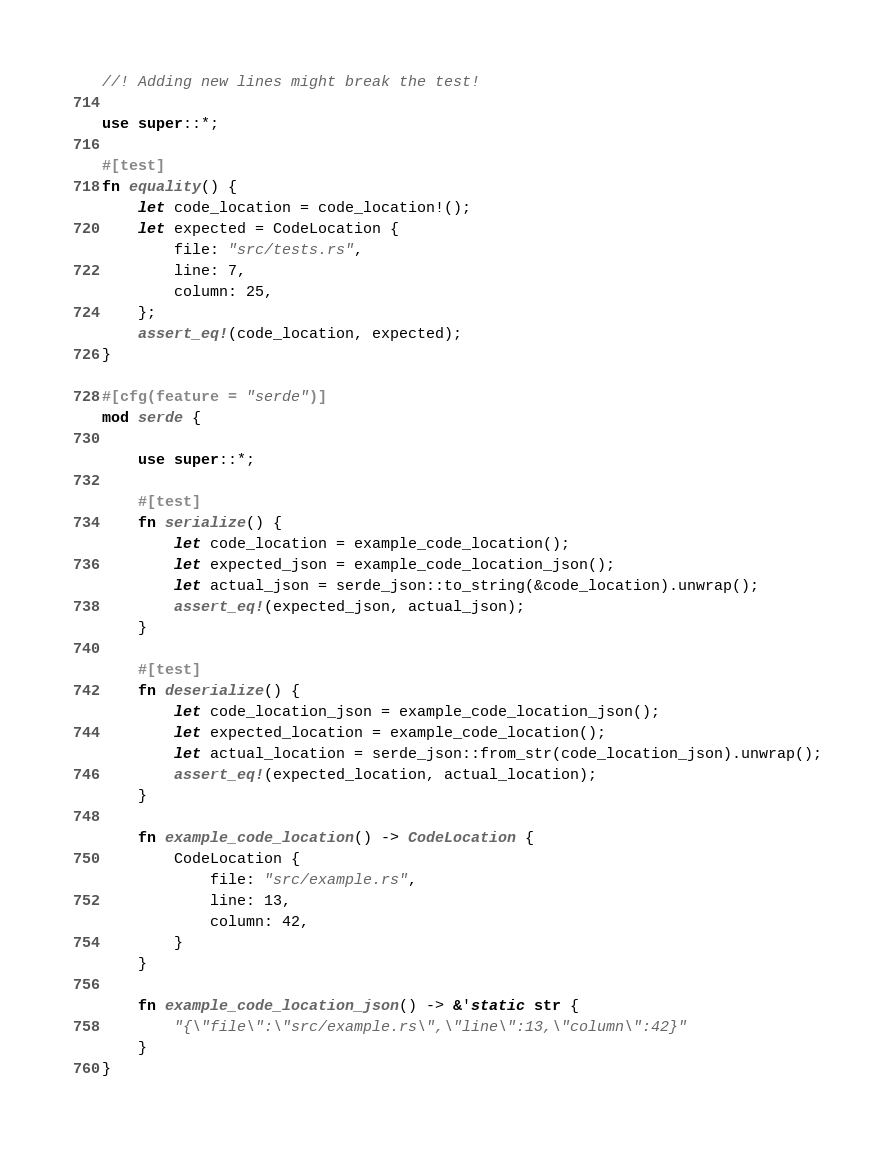Convert code to text. <code><loc_0><loc_0><loc_500><loc_500><_Rust_>//! Adding new lines might break the test!

use super::*;

#[test]
fn equality() {
    let code_location = code_location!();
    let expected = CodeLocation {
        file: "src/tests.rs",
        line: 7,
        column: 25,
    };
    assert_eq!(code_location, expected);
}

#[cfg(feature = "serde")]
mod serde {

    use super::*;

    #[test]
    fn serialize() {
        let code_location = example_code_location();
        let expected_json = example_code_location_json();
        let actual_json = serde_json::to_string(&code_location).unwrap();
        assert_eq!(expected_json, actual_json);
    }

    #[test]
    fn deserialize() {
        let code_location_json = example_code_location_json();
        let expected_location = example_code_location();
        let actual_location = serde_json::from_str(code_location_json).unwrap();
        assert_eq!(expected_location, actual_location);
    }

    fn example_code_location() -> CodeLocation {
        CodeLocation {
            file: "src/example.rs",
            line: 13,
            column: 42,
        }
    }

    fn example_code_location_json() -> &'static str {
        "{\"file\":\"src/example.rs\",\"line\":13,\"column\":42}"
    }
}
</code> 